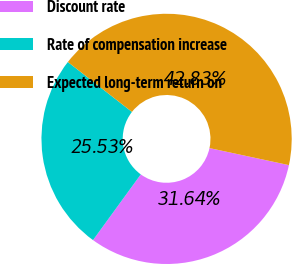Convert chart. <chart><loc_0><loc_0><loc_500><loc_500><pie_chart><fcel>Discount rate<fcel>Rate of compensation increase<fcel>Expected long-term return on<nl><fcel>31.64%<fcel>25.53%<fcel>42.83%<nl></chart> 